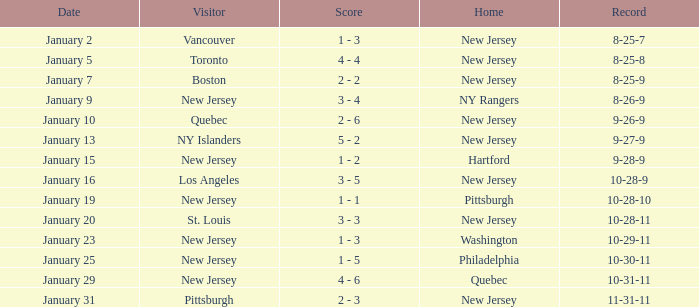What was the date that ended in a record of 8-25-7? January 2. 